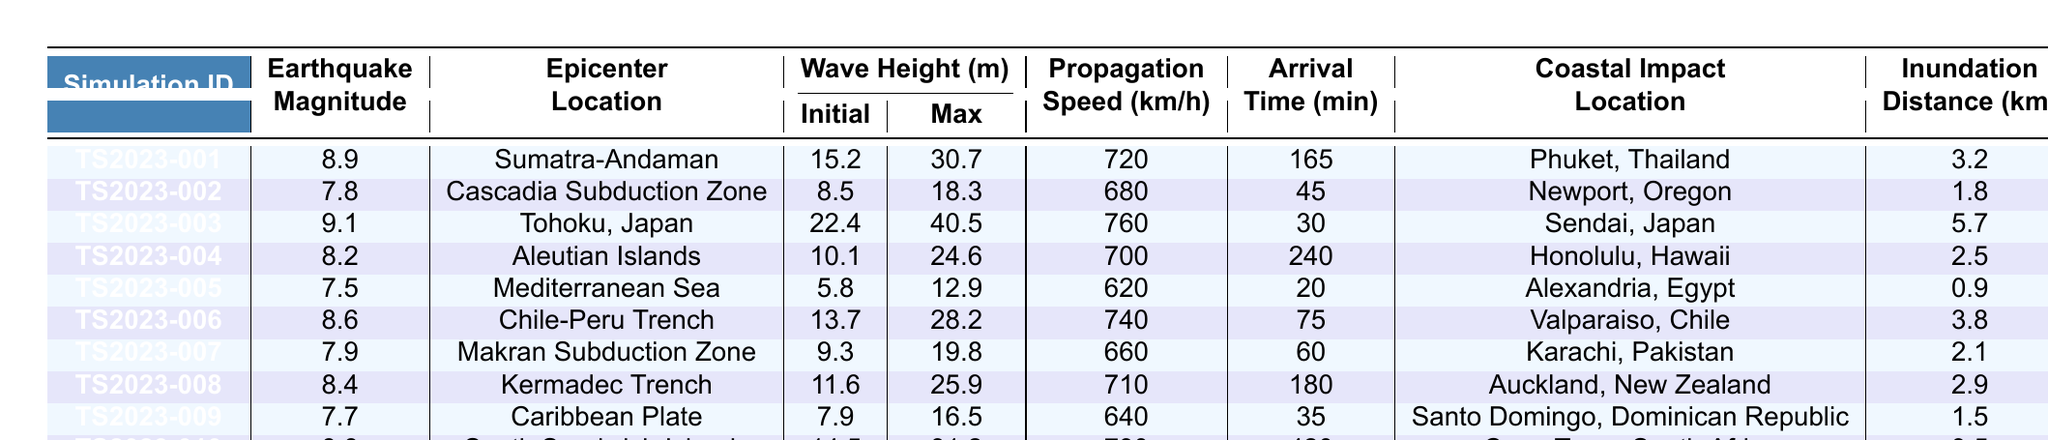What is the maximum wave height recorded in the simulations? To find the maximum wave height, I will look at the 'Max Wave Height (m)' column in the table. The largest value in that column is 40.5 meters from the simulation TS2023-003.
Answer: 40.5 Which simulation had the highest earthquake magnitude? By examining the 'Earthquake Magnitude' column, the highest magnitude is 9.1, which corresponds to the simulation TS2023-003 for Tohoku, Japan.
Answer: 9.1 How many simulations had an arrival time of more than 180 minutes? I will check the 'Arrival Time (min)' column to see how many entries are greater than 180. Only the simulation TS2023-004 shows an arrival time of 240 minutes.
Answer: 1 What is the average propagation speed of the tsunamis from all simulations? I will sum all the values in the 'Propagation Speed (km/h)' column: 720 + 680 + 760 + 700 + 620 + 740 + 660 + 710 + 640 + 730 = 7160 km/h. There are 10 simulations, so the average speed is 7160/10 = 716 km/h.
Answer: 716 Which coastal impact location had the lowest inundation distance? Inspecting the 'Inundation Distance (km)' column, the lowest value is 0.9 km for the simulation TS2023-005 in Alexandria, Egypt.
Answer: Alexandria, Egypt Did any simulation have a max wave height less than 15 meters? By reviewing the 'Max Wave Height (m)' column, I can see that there are two simulations (TS2023-002 and TS2023-005) with maximum wave heights of 18.3 meters and 12.9 meters, respectively. Thus, one simulation had a max height less than 15 meters.
Answer: Yes What is the difference in max wave height between the simulations TS2023-001 and TS2023-003? The max wave height for TS2023-001 is 30.7 m and for TS2023-003 it is 40.5 m. The difference is 40.5 - 30.7 = 9.8 meters.
Answer: 9.8 Which simulation had the highest initial wave height, and what was the coastal impact location? Checking the 'Initial Wave Height (m)', the highest is 22.4 m from simulation TS2023-003, which impacted Sendai, Japan.
Answer: Sendai, Japan What is the total inundation distance of all simulations? The total inundation distance can be calculated by summing all the values in the 'Inundation Distance (km)' column: 3.2 + 1.8 + 5.7 + 2.5 + 0.9 + 3.8 + 2.1 + 2.9 + 1.5 + 3.5 = 23.5 km.
Answer: 23.5 How many simulations occurred in the Pacific Ocean? By identifying the 'Epicenter Location', the simulations in the Pacific Ocean are TS2023-001 (Sumatra-Andaman), TS2023-003 (Tohoku), TS2023-004 (Aleutian Islands), TS2023-006 (Chile-Peru Trench), TS2023-007 (Makran), TS2023-008 (Kermadec). There are 6 in total.
Answer: 6 